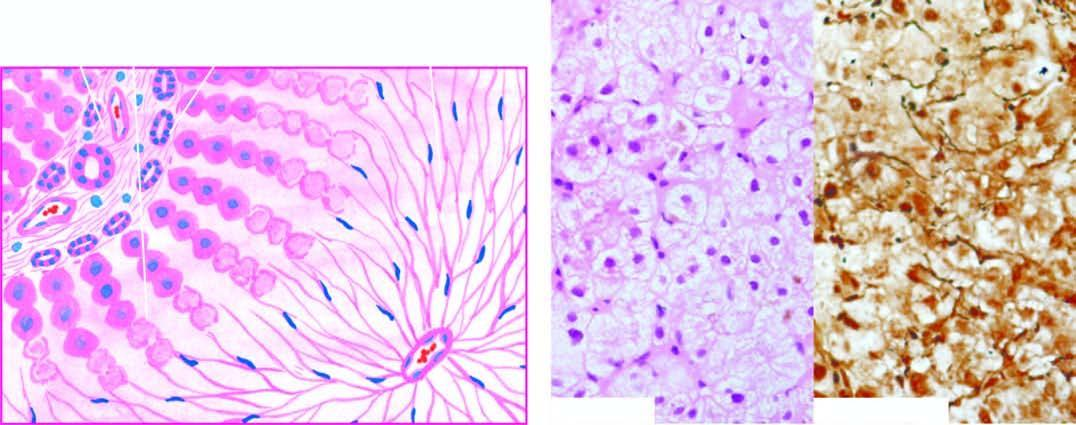what left out in their place, high lighted by reticulin stain?
Answer the question using a single word or phrase. Collapsed reticulin framework 